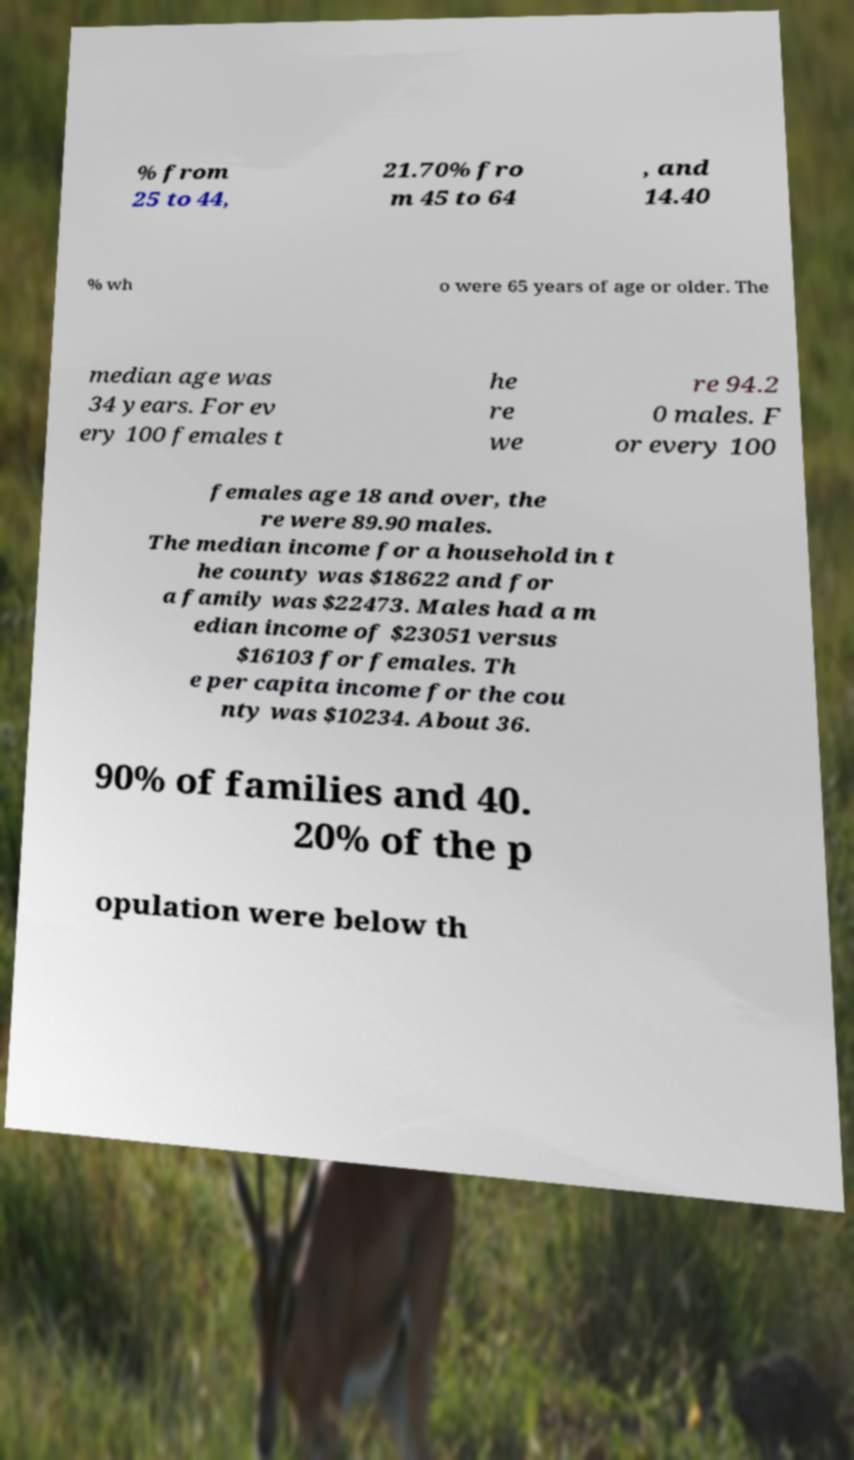Please read and relay the text visible in this image. What does it say? % from 25 to 44, 21.70% fro m 45 to 64 , and 14.40 % wh o were 65 years of age or older. The median age was 34 years. For ev ery 100 females t he re we re 94.2 0 males. F or every 100 females age 18 and over, the re were 89.90 males. The median income for a household in t he county was $18622 and for a family was $22473. Males had a m edian income of $23051 versus $16103 for females. Th e per capita income for the cou nty was $10234. About 36. 90% of families and 40. 20% of the p opulation were below th 